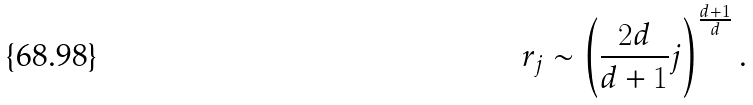<formula> <loc_0><loc_0><loc_500><loc_500>r _ { j } \sim \left ( \frac { 2 d } { d + 1 } j \right ) ^ { \frac { d + 1 } { d } } .</formula> 